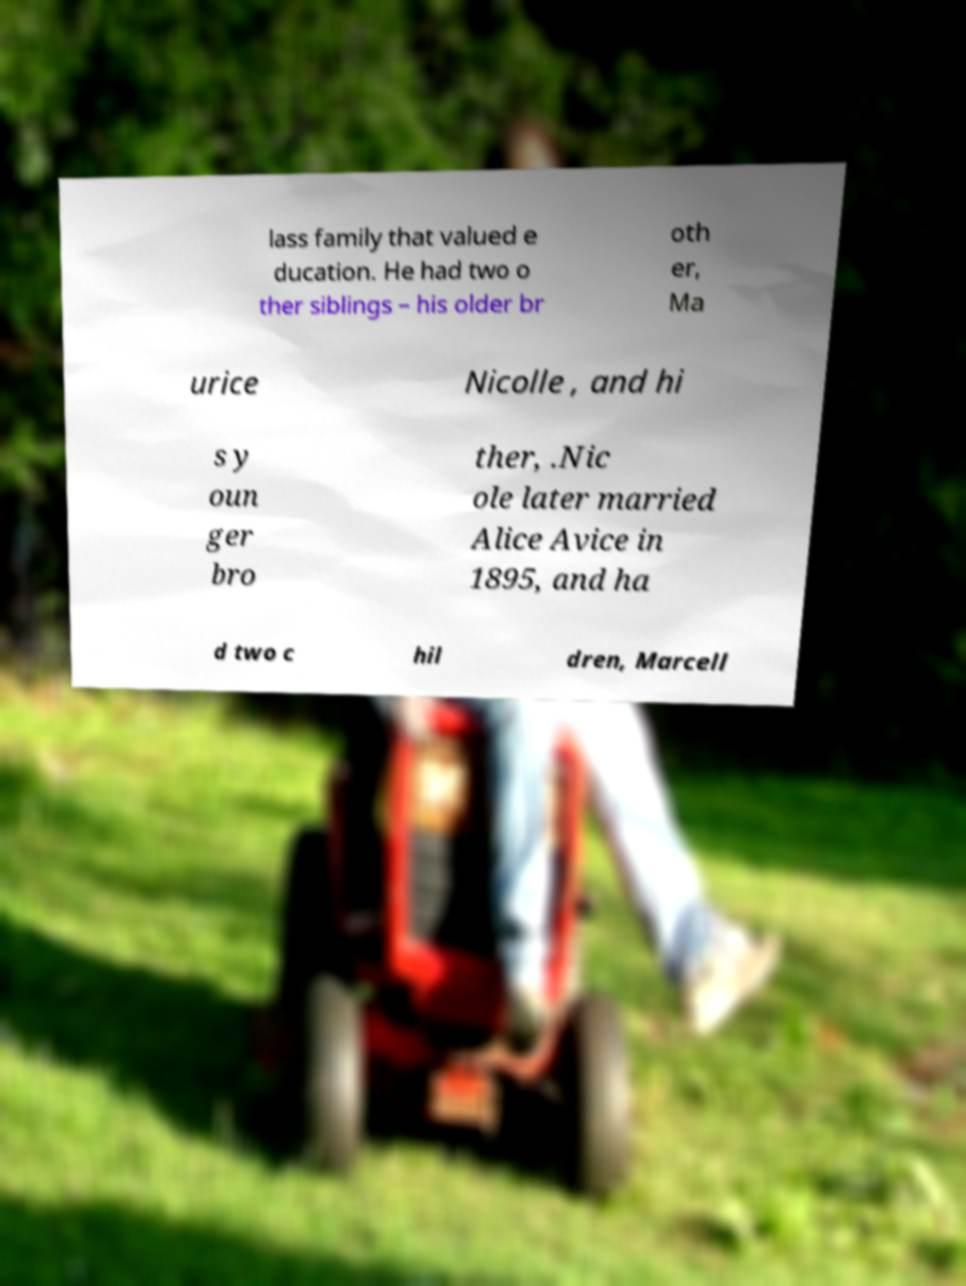What messages or text are displayed in this image? I need them in a readable, typed format. lass family that valued e ducation. He had two o ther siblings – his older br oth er, Ma urice Nicolle , and hi s y oun ger bro ther, .Nic ole later married Alice Avice in 1895, and ha d two c hil dren, Marcell 